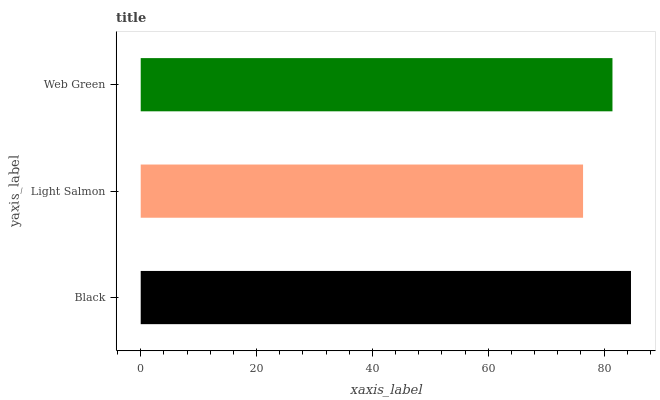Is Light Salmon the minimum?
Answer yes or no. Yes. Is Black the maximum?
Answer yes or no. Yes. Is Web Green the minimum?
Answer yes or no. No. Is Web Green the maximum?
Answer yes or no. No. Is Web Green greater than Light Salmon?
Answer yes or no. Yes. Is Light Salmon less than Web Green?
Answer yes or no. Yes. Is Light Salmon greater than Web Green?
Answer yes or no. No. Is Web Green less than Light Salmon?
Answer yes or no. No. Is Web Green the high median?
Answer yes or no. Yes. Is Web Green the low median?
Answer yes or no. Yes. Is Light Salmon the high median?
Answer yes or no. No. Is Black the low median?
Answer yes or no. No. 